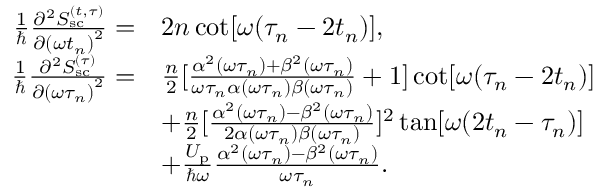<formula> <loc_0><loc_0><loc_500><loc_500>\begin{array} { r l } { \frac { 1 } { } \frac { \partial ^ { 2 } S _ { s c } ^ { ( t , \tau ) } } { \partial { ( \omega t _ { n } ) } ^ { 2 } } = } & { 2 n \cot [ \omega ( \tau _ { n } - 2 t _ { n } ) ] , } \\ { \frac { 1 } { } \frac { \partial ^ { 2 } S _ { s c } ^ { ( \tau ) } } { \partial { ( \omega \tau _ { n } ) } ^ { 2 } } = } & { \frac { n } { 2 } [ \frac { \alpha ^ { 2 } ( \omega \tau _ { n } ) + \beta ^ { 2 } ( \omega \tau _ { n } ) } { \omega \tau _ { n } \alpha ( \omega \tau _ { n } ) \beta ( \omega \tau _ { n } ) } + 1 ] \cot [ \omega ( \tau _ { n } - 2 t _ { n } ) ] } \\ & { + \frac { n } { 2 } [ \frac { \alpha ^ { 2 } ( \omega \tau _ { n } ) - \beta ^ { 2 } ( \omega \tau _ { n } ) } { 2 \alpha ( \omega \tau _ { n } ) \beta ( \omega \tau _ { n } ) } ] ^ { 2 } \tan [ \omega ( 2 t _ { n } - \tau _ { n } ) ] } \\ & { + \frac { U _ { p } } { \hbar { \omega } } \frac { \alpha ^ { 2 } ( \omega \tau _ { n } ) - \beta ^ { 2 } ( \omega \tau _ { n } ) } { \omega \tau _ { n } } . } \end{array}</formula> 